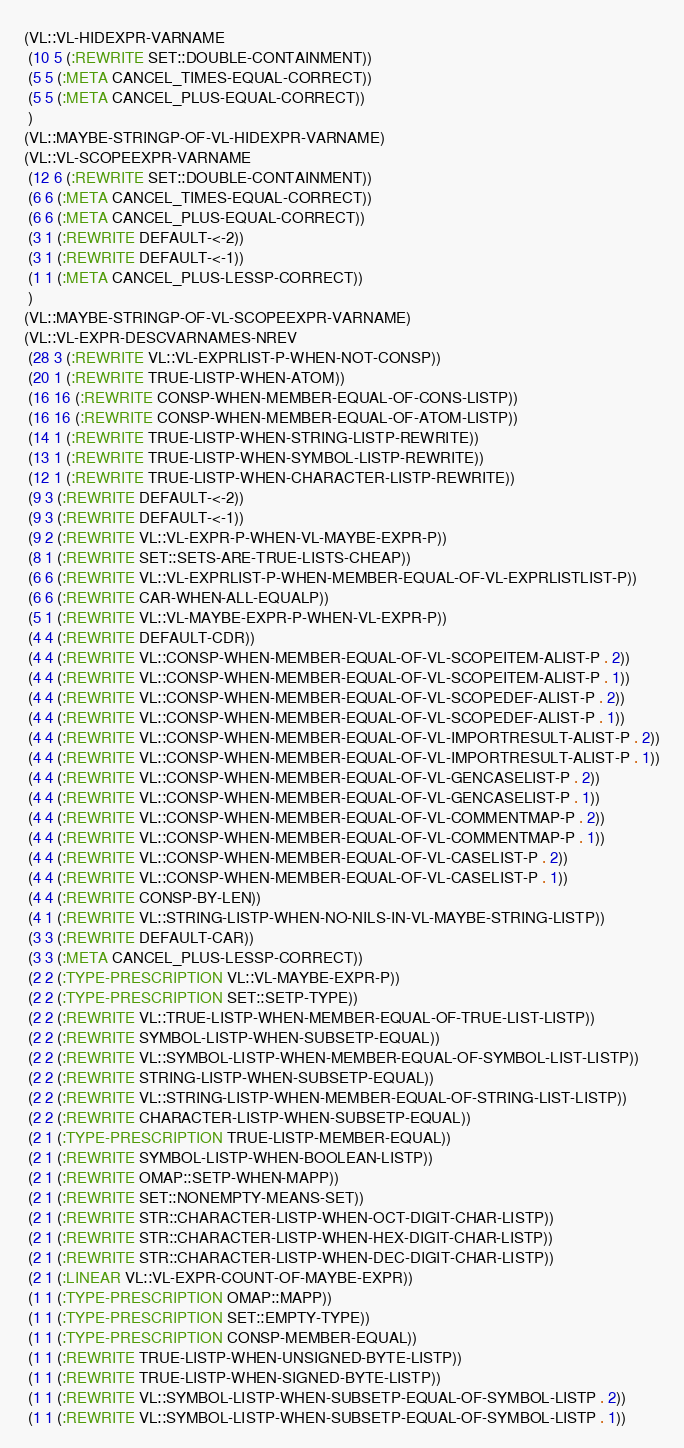Convert code to text. <code><loc_0><loc_0><loc_500><loc_500><_Lisp_>(VL::VL-HIDEXPR-VARNAME
 (10 5 (:REWRITE SET::DOUBLE-CONTAINMENT))
 (5 5 (:META CANCEL_TIMES-EQUAL-CORRECT))
 (5 5 (:META CANCEL_PLUS-EQUAL-CORRECT))
 )
(VL::MAYBE-STRINGP-OF-VL-HIDEXPR-VARNAME)
(VL::VL-SCOPEEXPR-VARNAME
 (12 6 (:REWRITE SET::DOUBLE-CONTAINMENT))
 (6 6 (:META CANCEL_TIMES-EQUAL-CORRECT))
 (6 6 (:META CANCEL_PLUS-EQUAL-CORRECT))
 (3 1 (:REWRITE DEFAULT-<-2))
 (3 1 (:REWRITE DEFAULT-<-1))
 (1 1 (:META CANCEL_PLUS-LESSP-CORRECT))
 )
(VL::MAYBE-STRINGP-OF-VL-SCOPEEXPR-VARNAME)
(VL::VL-EXPR-DESCVARNAMES-NREV
 (28 3 (:REWRITE VL::VL-EXPRLIST-P-WHEN-NOT-CONSP))
 (20 1 (:REWRITE TRUE-LISTP-WHEN-ATOM))
 (16 16 (:REWRITE CONSP-WHEN-MEMBER-EQUAL-OF-CONS-LISTP))
 (16 16 (:REWRITE CONSP-WHEN-MEMBER-EQUAL-OF-ATOM-LISTP))
 (14 1 (:REWRITE TRUE-LISTP-WHEN-STRING-LISTP-REWRITE))
 (13 1 (:REWRITE TRUE-LISTP-WHEN-SYMBOL-LISTP-REWRITE))
 (12 1 (:REWRITE TRUE-LISTP-WHEN-CHARACTER-LISTP-REWRITE))
 (9 3 (:REWRITE DEFAULT-<-2))
 (9 3 (:REWRITE DEFAULT-<-1))
 (9 2 (:REWRITE VL::VL-EXPR-P-WHEN-VL-MAYBE-EXPR-P))
 (8 1 (:REWRITE SET::SETS-ARE-TRUE-LISTS-CHEAP))
 (6 6 (:REWRITE VL::VL-EXPRLIST-P-WHEN-MEMBER-EQUAL-OF-VL-EXPRLISTLIST-P))
 (6 6 (:REWRITE CAR-WHEN-ALL-EQUALP))
 (5 1 (:REWRITE VL::VL-MAYBE-EXPR-P-WHEN-VL-EXPR-P))
 (4 4 (:REWRITE DEFAULT-CDR))
 (4 4 (:REWRITE VL::CONSP-WHEN-MEMBER-EQUAL-OF-VL-SCOPEITEM-ALIST-P . 2))
 (4 4 (:REWRITE VL::CONSP-WHEN-MEMBER-EQUAL-OF-VL-SCOPEITEM-ALIST-P . 1))
 (4 4 (:REWRITE VL::CONSP-WHEN-MEMBER-EQUAL-OF-VL-SCOPEDEF-ALIST-P . 2))
 (4 4 (:REWRITE VL::CONSP-WHEN-MEMBER-EQUAL-OF-VL-SCOPEDEF-ALIST-P . 1))
 (4 4 (:REWRITE VL::CONSP-WHEN-MEMBER-EQUAL-OF-VL-IMPORTRESULT-ALIST-P . 2))
 (4 4 (:REWRITE VL::CONSP-WHEN-MEMBER-EQUAL-OF-VL-IMPORTRESULT-ALIST-P . 1))
 (4 4 (:REWRITE VL::CONSP-WHEN-MEMBER-EQUAL-OF-VL-GENCASELIST-P . 2))
 (4 4 (:REWRITE VL::CONSP-WHEN-MEMBER-EQUAL-OF-VL-GENCASELIST-P . 1))
 (4 4 (:REWRITE VL::CONSP-WHEN-MEMBER-EQUAL-OF-VL-COMMENTMAP-P . 2))
 (4 4 (:REWRITE VL::CONSP-WHEN-MEMBER-EQUAL-OF-VL-COMMENTMAP-P . 1))
 (4 4 (:REWRITE VL::CONSP-WHEN-MEMBER-EQUAL-OF-VL-CASELIST-P . 2))
 (4 4 (:REWRITE VL::CONSP-WHEN-MEMBER-EQUAL-OF-VL-CASELIST-P . 1))
 (4 4 (:REWRITE CONSP-BY-LEN))
 (4 1 (:REWRITE VL::STRING-LISTP-WHEN-NO-NILS-IN-VL-MAYBE-STRING-LISTP))
 (3 3 (:REWRITE DEFAULT-CAR))
 (3 3 (:META CANCEL_PLUS-LESSP-CORRECT))
 (2 2 (:TYPE-PRESCRIPTION VL::VL-MAYBE-EXPR-P))
 (2 2 (:TYPE-PRESCRIPTION SET::SETP-TYPE))
 (2 2 (:REWRITE VL::TRUE-LISTP-WHEN-MEMBER-EQUAL-OF-TRUE-LIST-LISTP))
 (2 2 (:REWRITE SYMBOL-LISTP-WHEN-SUBSETP-EQUAL))
 (2 2 (:REWRITE VL::SYMBOL-LISTP-WHEN-MEMBER-EQUAL-OF-SYMBOL-LIST-LISTP))
 (2 2 (:REWRITE STRING-LISTP-WHEN-SUBSETP-EQUAL))
 (2 2 (:REWRITE VL::STRING-LISTP-WHEN-MEMBER-EQUAL-OF-STRING-LIST-LISTP))
 (2 2 (:REWRITE CHARACTER-LISTP-WHEN-SUBSETP-EQUAL))
 (2 1 (:TYPE-PRESCRIPTION TRUE-LISTP-MEMBER-EQUAL))
 (2 1 (:REWRITE SYMBOL-LISTP-WHEN-BOOLEAN-LISTP))
 (2 1 (:REWRITE OMAP::SETP-WHEN-MAPP))
 (2 1 (:REWRITE SET::NONEMPTY-MEANS-SET))
 (2 1 (:REWRITE STR::CHARACTER-LISTP-WHEN-OCT-DIGIT-CHAR-LISTP))
 (2 1 (:REWRITE STR::CHARACTER-LISTP-WHEN-HEX-DIGIT-CHAR-LISTP))
 (2 1 (:REWRITE STR::CHARACTER-LISTP-WHEN-DEC-DIGIT-CHAR-LISTP))
 (2 1 (:LINEAR VL::VL-EXPR-COUNT-OF-MAYBE-EXPR))
 (1 1 (:TYPE-PRESCRIPTION OMAP::MAPP))
 (1 1 (:TYPE-PRESCRIPTION SET::EMPTY-TYPE))
 (1 1 (:TYPE-PRESCRIPTION CONSP-MEMBER-EQUAL))
 (1 1 (:REWRITE TRUE-LISTP-WHEN-UNSIGNED-BYTE-LISTP))
 (1 1 (:REWRITE TRUE-LISTP-WHEN-SIGNED-BYTE-LISTP))
 (1 1 (:REWRITE VL::SYMBOL-LISTP-WHEN-SUBSETP-EQUAL-OF-SYMBOL-LISTP . 2))
 (1 1 (:REWRITE VL::SYMBOL-LISTP-WHEN-SUBSETP-EQUAL-OF-SYMBOL-LISTP . 1))</code> 